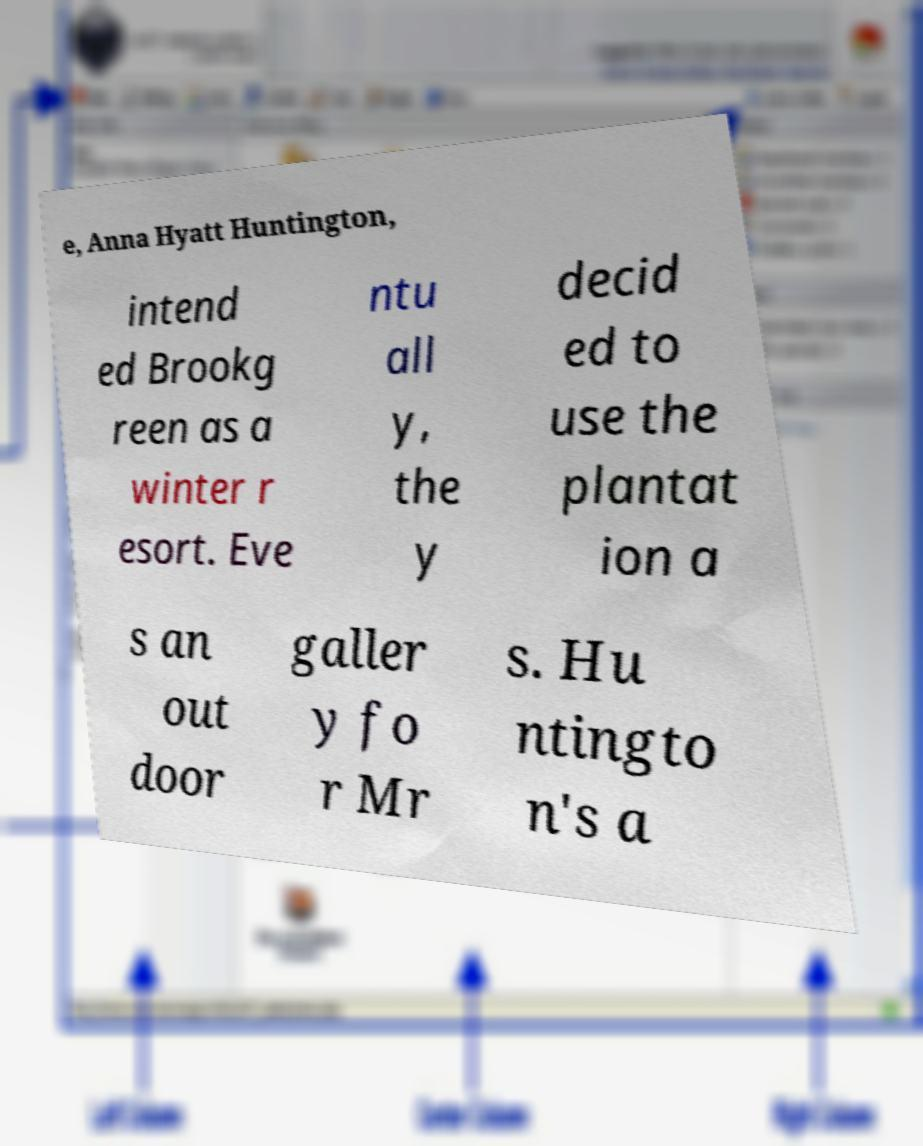Please identify and transcribe the text found in this image. e, Anna Hyatt Huntington, intend ed Brookg reen as a winter r esort. Eve ntu all y, the y decid ed to use the plantat ion a s an out door galler y fo r Mr s. Hu ntingto n's a 